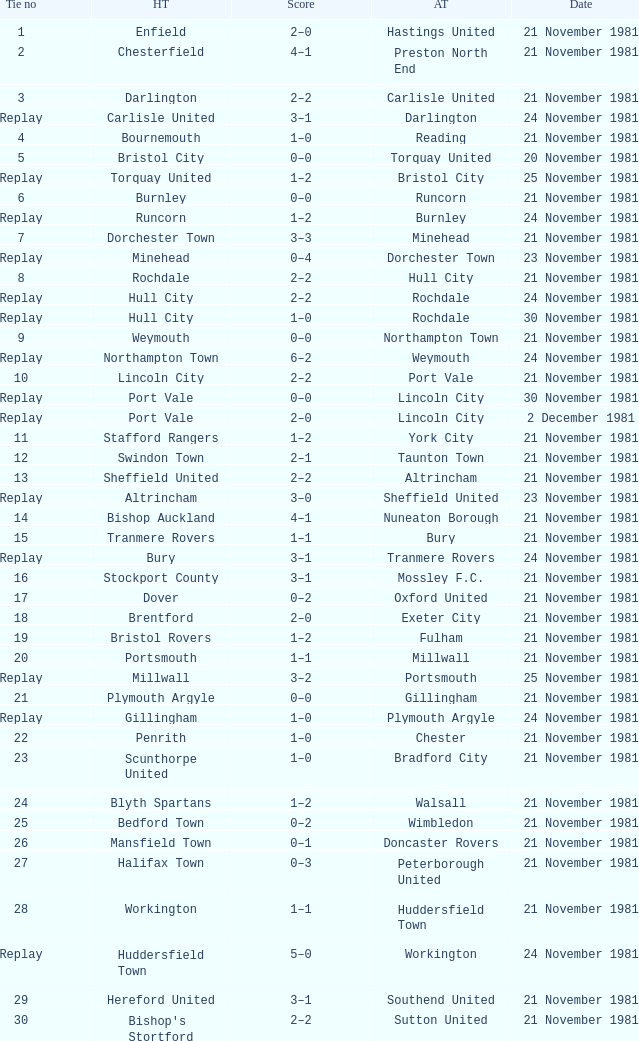Minehead has what tie number? Replay. 